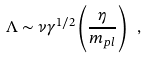<formula> <loc_0><loc_0><loc_500><loc_500>\Lambda \sim \nu \gamma ^ { 1 / 2 } \left ( \frac { \eta } { m _ { p l } } \right ) \ ,</formula> 